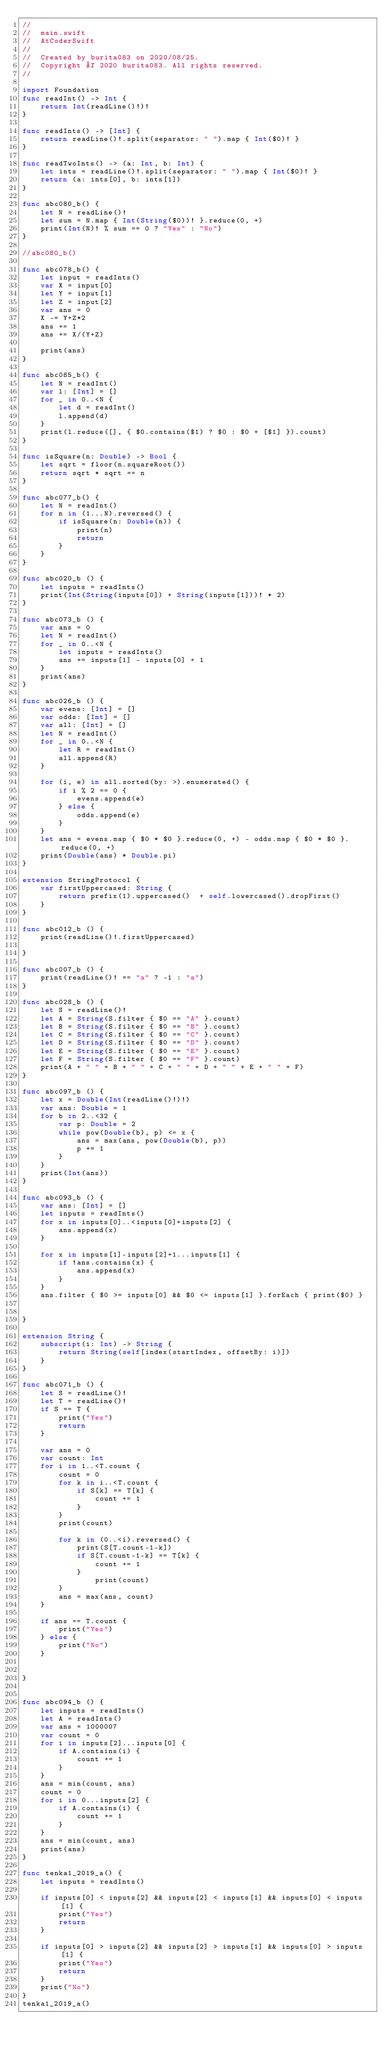<code> <loc_0><loc_0><loc_500><loc_500><_Swift_>//
//  main.swift
//  AtCoderSwift
//
//  Created by burita083 on 2020/08/25.
//  Copyright © 2020 burita083. All rights reserved.
//

import Foundation
func readInt() -> Int {
    return Int(readLine()!)!
}
 
func readInts() -> [Int] {
    return readLine()!.split(separator: " ").map { Int($0)! }
}
 
func readTwoInts() -> (a: Int, b: Int) {
    let ints = readLine()!.split(separator: " ").map { Int($0)! }
    return (a: ints[0], b: ints[1])
}

func abc080_b() {
    let N = readLine()!
    let sum = N.map { Int(String($0))! }.reduce(0, +)
    print(Int(N)! % sum == 0 ? "Yes" : "No")
}

//abc080_b()

func abc078_b() {
    let input = readInts()
    var X = input[0]
    let Y = input[1]
    let Z = input[2]
    var ans = 0
    X -= Y+Z*2
    ans += 1
    ans += X/(Y+Z)
    
    print(ans)
}

func abc085_b() {
    let N = readInt()
    var l: [Int] = []
    for _ in 0..<N {
        let d = readInt()
        l.append(d)
    }
    print(l.reduce([], { $0.contains($1) ? $0 : $0 + [$1] }).count)
}

func isSquare(n: Double) -> Bool {
    let sqrt = floor(n.squareRoot())
    return sqrt * sqrt == n
}

func abc077_b() {
    let N = readInt()
    for n in (1...N).reversed() {
        if isSquare(n: Double(n)) {
            print(n)
            return
        }
    }
}

func abc020_b () {
    let inputs = readInts()
    print(Int(String(inputs[0]) + String(inputs[1]))! * 2)
}

func abc073_b () {
    var ans = 0
    let N = readInt()
    for _ in 0..<N {
        let inputs = readInts()
        ans += inputs[1] - inputs[0] + 1
    }
    print(ans)
}

func abc026_b () {
    var evens: [Int] = []
    var odds: [Int] = []
    var all: [Int] = []
    let N = readInt()
    for _ in 0..<N {
        let R = readInt()
        all.append(R)
    }

    for (i, e) in all.sorted(by: >).enumerated() {
        if i % 2 == 0 {
            evens.append(e)
        } else {
            odds.append(e)
        }
    }
    let ans = evens.map { $0 * $0 }.reduce(0, +) - odds.map { $0 * $0 }.reduce(0, +)
    print(Double(ans) * Double.pi)
}

extension StringProtocol {
    var firstUppercased: String {
        return prefix(1).uppercased()  + self.lowercased().dropFirst()
    }
}

func abc012_b () {
    print(readLine()!.firstUppercased)

}

func abc007_b () {
    print(readLine()! == "a" ? -1 : "a")
}

func abc028_b () {
    let S = readLine()!
    let A = String(S.filter { $0 == "A" }.count)
    let B = String(S.filter { $0 == "B" }.count)
    let C = String(S.filter { $0 == "C" }.count)
    let D = String(S.filter { $0 == "D" }.count)
    let E = String(S.filter { $0 == "E" }.count)
    let F = String(S.filter { $0 == "F" }.count)
    print(A + " " + B + " " + C + " " + D + " " + E + " " + F)
}

func abc097_b () {
    let x = Double(Int(readLine()!)!)
    var ans: Double = 1
    for b in 2..<32 {
        var p: Double = 2
        while pow(Double(b), p) <= x {
            ans = max(ans, pow(Double(b), p))
            p += 1
        }
    }
    print(Int(ans))
}

func abc093_b () {
    var ans: [Int] = []
    let inputs = readInts()
    for x in inputs[0]..<inputs[0]+inputs[2] {
        ans.append(x)
    }
    
    for x in inputs[1]-inputs[2]+1...inputs[1] {
        if !ans.contains(x) {
            ans.append(x)
        }
    }
    ans.filter { $0 >= inputs[0] && $0 <= inputs[1] }.forEach { print($0) }
        

}

extension String {
    subscript(i: Int) -> String {
        return String(self[index(startIndex, offsetBy: i)])
    }
}

func abc071_b () {
    let S = readLine()!
    let T = readLine()!
    if S == T {
        print("Yes")
        return
    }
    
    var ans = 0
    var count: Int
    for i in 1..<T.count {
        count = 0
        for k in i..<T.count {
            if S[k] == T[k] {
                count += 1
            }
        }
        print(count)
        
        for k in (0..<i).reversed() {
            print(S[T.count-1-k])
            if S[T.count-1-k] == T[k] {
                count += 1
            }
                print(count)
        }
        ans = max(ans, count)
    }
    
    if ans == T.count {
        print("Yes")
    } else {
        print("No")
    }
    

}


func abc094_b () {
    let inputs = readInts()
    let A = readInts()
    var ans = 1000007
    var count = 0
    for i in inputs[2]...inputs[0] {
        if A.contains(i) {
            count += 1
        }
    }
    ans = min(count, ans)
    count = 0
    for i in 0...inputs[2] {
        if A.contains(i) {
            count += 1
        }
    }
    ans = min(count, ans)
    print(ans)
}

func tenka1_2019_a() {
    let inputs = readInts()
    
    if inputs[0] < inputs[2] && inputs[2] < inputs[1] && inputs[0] < inputs[1] {
        print("Yes")
        return
    }
    
    if inputs[0] > inputs[2] && inputs[2] > inputs[1] && inputs[0] > inputs[1] {
        print("Yes")
        return
    }
    print("No")
}
tenka1_2019_a()
</code> 